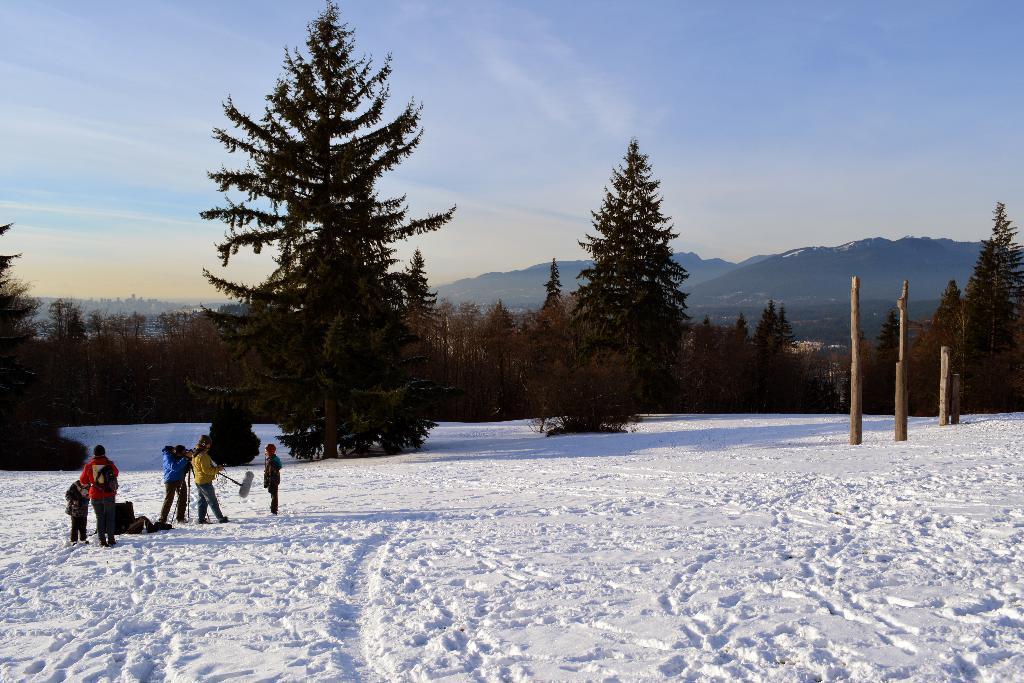Can you describe this image briefly? In this picture there are mountains and trees. In the foreground there are pillars and there are group of people standing and there are objects. At the top there is sky and there are clouds. At the bottom there is snow. 